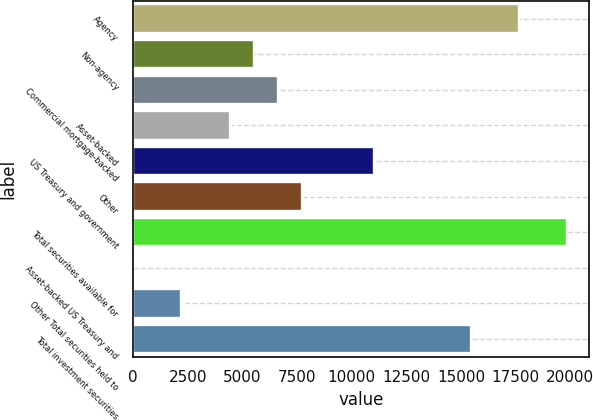Convert chart. <chart><loc_0><loc_0><loc_500><loc_500><bar_chart><fcel>Agency<fcel>Non-agency<fcel>Commercial mortgage-backed<fcel>Asset-backed<fcel>US Treasury and government<fcel>Other<fcel>Total securities available for<fcel>Asset-backed US Treasury and<fcel>Other Total securities held to<fcel>Total investment securities<nl><fcel>17640.4<fcel>5519.5<fcel>6621.4<fcel>4417.6<fcel>11029<fcel>7723.3<fcel>19844.2<fcel>10<fcel>2213.8<fcel>15436.6<nl></chart> 